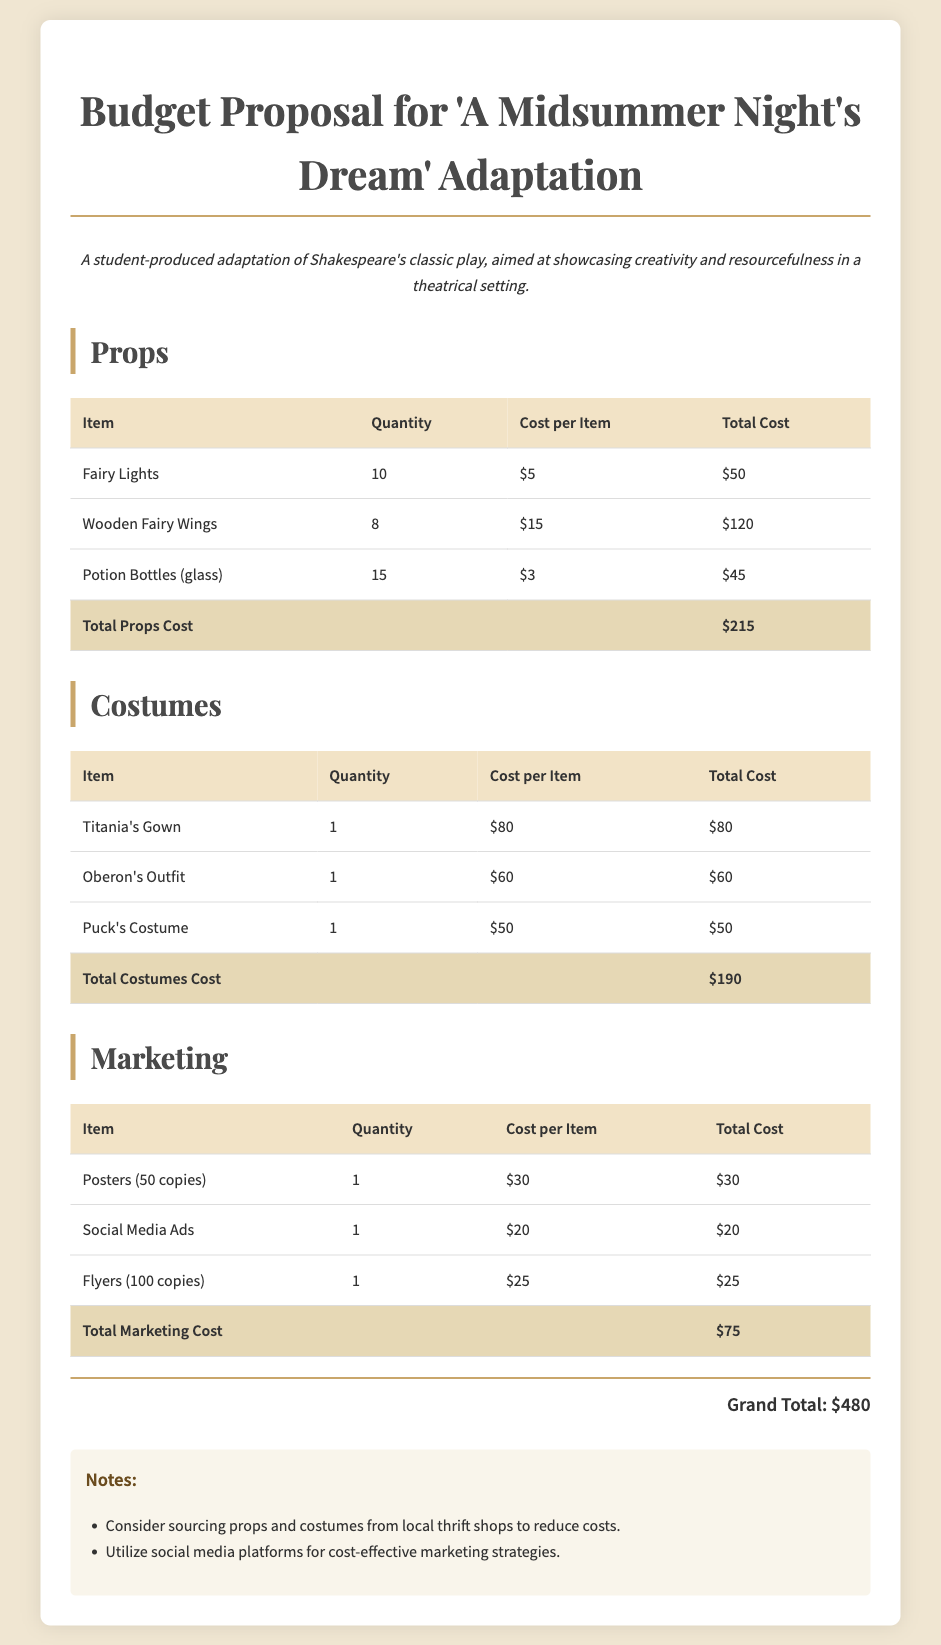What is the total cost for props? The total cost for props is listed in the document under the "Props" section, which is $215.
Answer: $215 How many wooden fairy wings are needed? The quantity of wooden fairy wings is provided in the props table, which states 8 are needed.
Answer: 8 What is the cost of Titania's gown? The cost of Titania's gown is specifically mentioned in the costumes table, which is $80.
Answer: $80 What is the total marketing cost? The total cost for marketing is found in the "Marketing" section, summed up to $75.
Answer: $75 What is the grand total of the budget? The grand total combines all sections of the budget in the document, which is $480.
Answer: $480 How many potion bottles are required? The document specifies that 15 potion bottles are needed, as per the props table.
Answer: 15 What types of advertising are included in the marketing section? The marketing section lists posters, social media ads, and flyers, indicating the forms of advertising used.
Answer: Posters, Social Media Ads, Flyers What are the notes about sourcing? The notes suggest considering local thrift shops to reduce costs for props and costumes.
Answer: Sourcing from local thrift shops How many copies of flyers are printed? The marketing section specifies that 100 copies of flyers will be printed.
Answer: 100 copies 